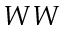Convert formula to latex. <formula><loc_0><loc_0><loc_500><loc_500>W W</formula> 